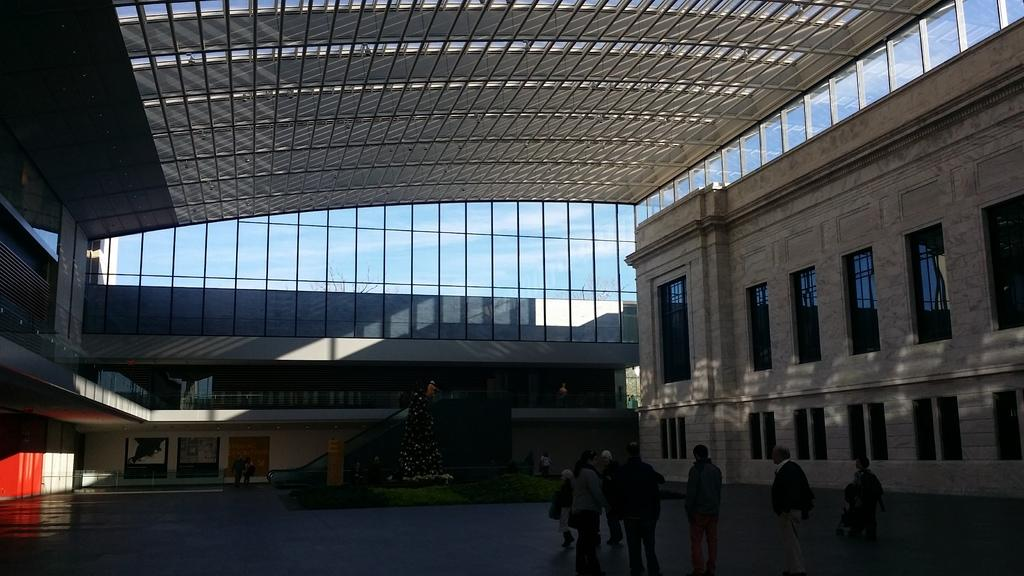What is the main object in the image? There is a Christmas tree in the image. Where is the Christmas tree located? The Christmas tree is on grassland. What can be seen in the background of the image? There is a staircase and buildings in the background of the image. Are there any people in the image? Yes, there are people on the floor in the image. What type of brick is used to build the shop in the image? There is no shop present in the image, so it is not possible to determine the type of brick used for construction. 